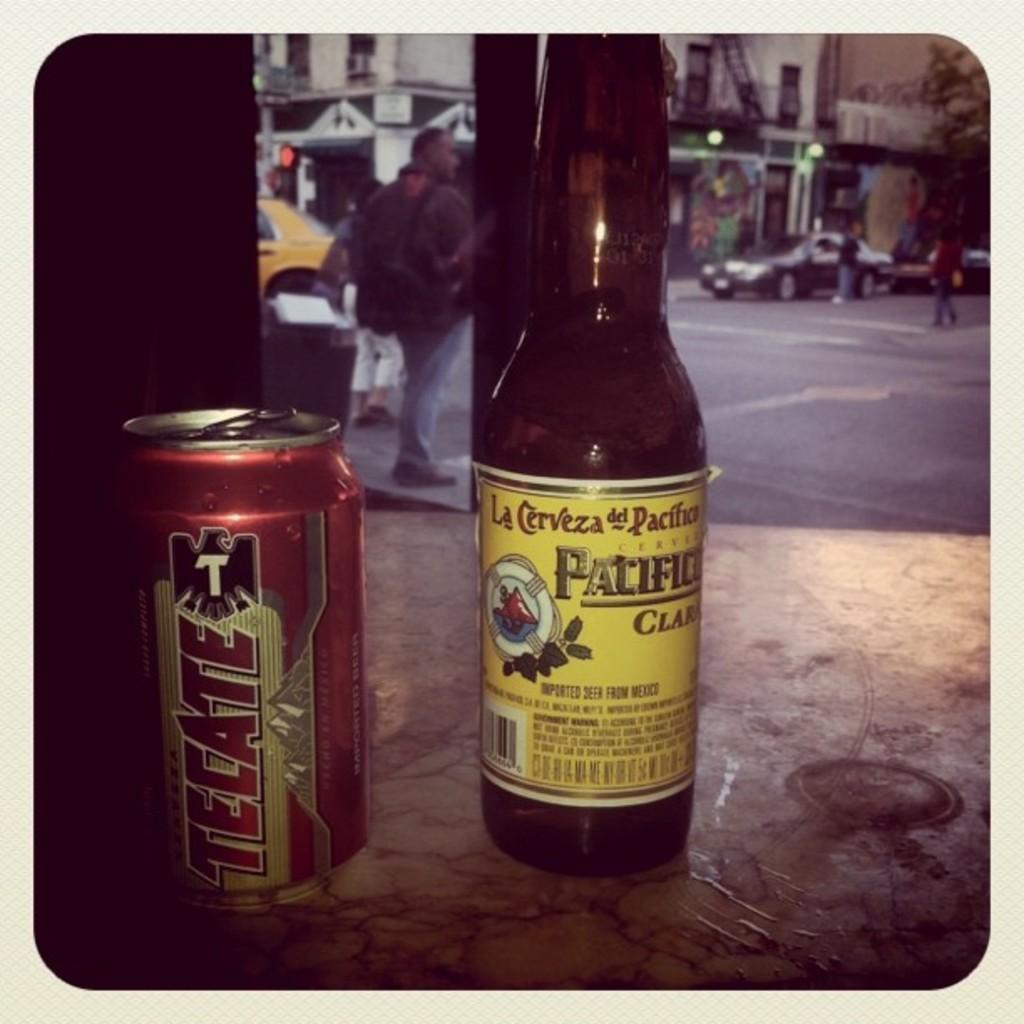<image>
Offer a succinct explanation of the picture presented. A bottle of Pacifico next to a can of Tecate. 